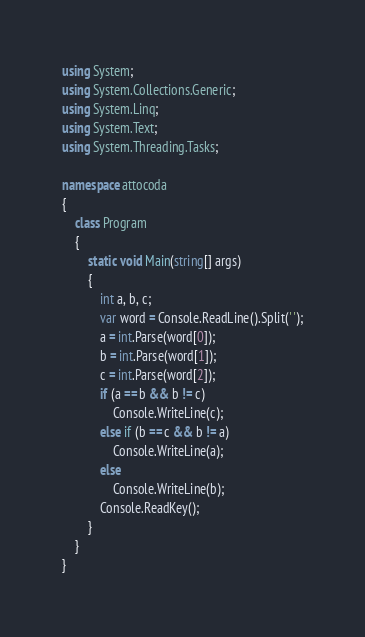Convert code to text. <code><loc_0><loc_0><loc_500><loc_500><_C#_>using System;
using System.Collections.Generic;
using System.Linq;
using System.Text;
using System.Threading.Tasks;

namespace attocoda
{
    class Program
    {
        static void Main(string[] args)
        {
            int a, b, c;
            var word = Console.ReadLine().Split(' ');
            a = int.Parse(word[0]);
            b = int.Parse(word[1]);
            c = int.Parse(word[2]);
            if (a == b && b != c)
                Console.WriteLine(c);
            else if (b == c && b != a)
                Console.WriteLine(a);
            else
                Console.WriteLine(b);
            Console.ReadKey();
        }
    }
}
</code> 